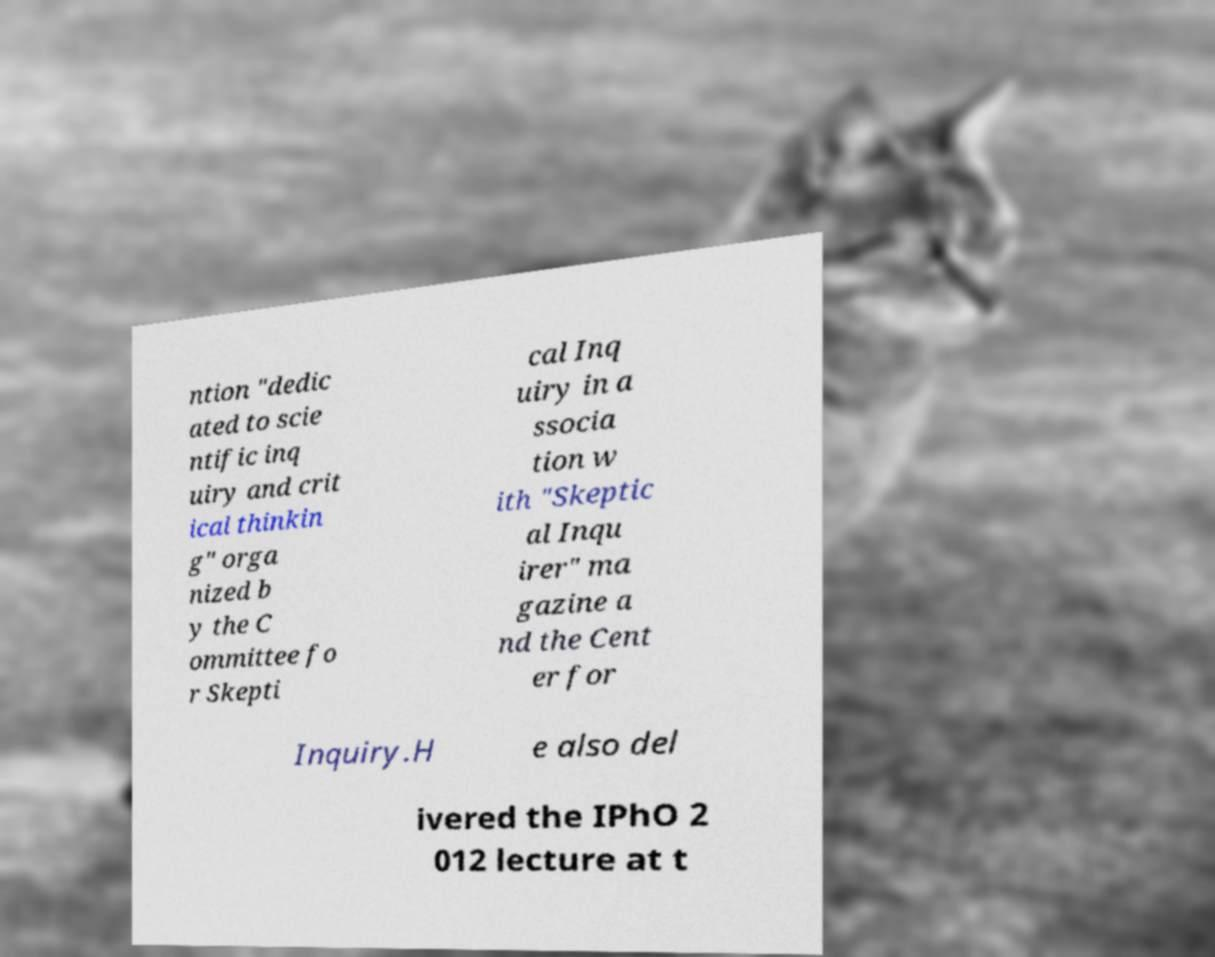Please read and relay the text visible in this image. What does it say? ntion "dedic ated to scie ntific inq uiry and crit ical thinkin g" orga nized b y the C ommittee fo r Skepti cal Inq uiry in a ssocia tion w ith "Skeptic al Inqu irer" ma gazine a nd the Cent er for Inquiry.H e also del ivered the IPhO 2 012 lecture at t 